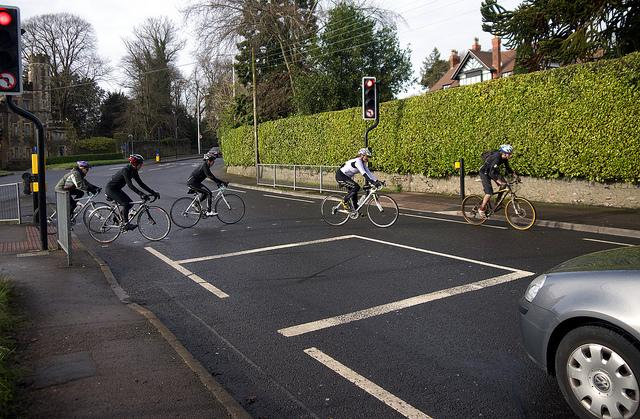If you're in a car coming from this way what is forbidden?

Choices:
A) going forwards
B) turning right
C) waiting
D) turning left turning left 